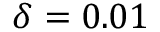<formula> <loc_0><loc_0><loc_500><loc_500>\delta = 0 . 0 1</formula> 